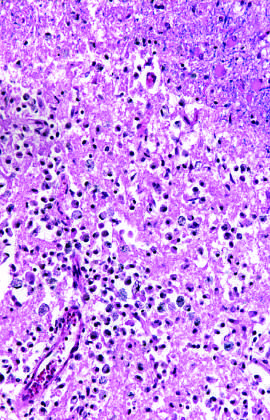when does an area of infarction show the presence of macrophages and surrounding reactive gliosis?
Answer the question using a single word or phrase. By day 10 